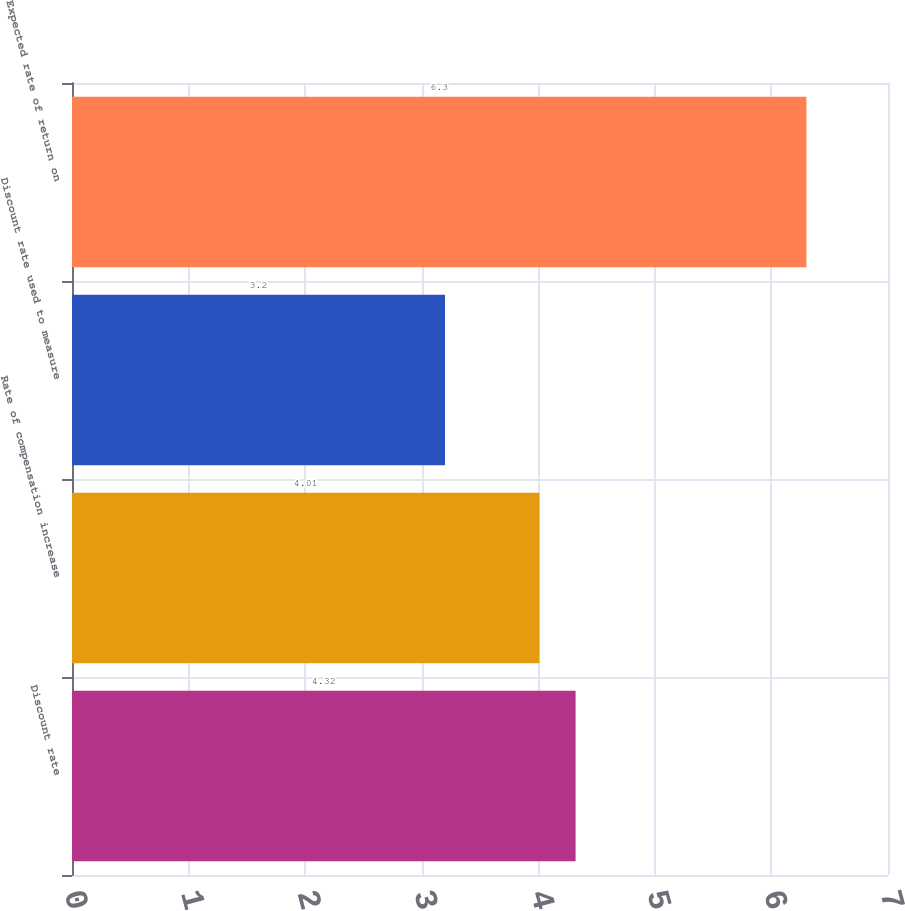Convert chart to OTSL. <chart><loc_0><loc_0><loc_500><loc_500><bar_chart><fcel>Discount rate<fcel>Rate of compensation increase<fcel>Discount rate used to measure<fcel>Expected rate of return on<nl><fcel>4.32<fcel>4.01<fcel>3.2<fcel>6.3<nl></chart> 